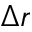<formula> <loc_0><loc_0><loc_500><loc_500>\Delta r</formula> 